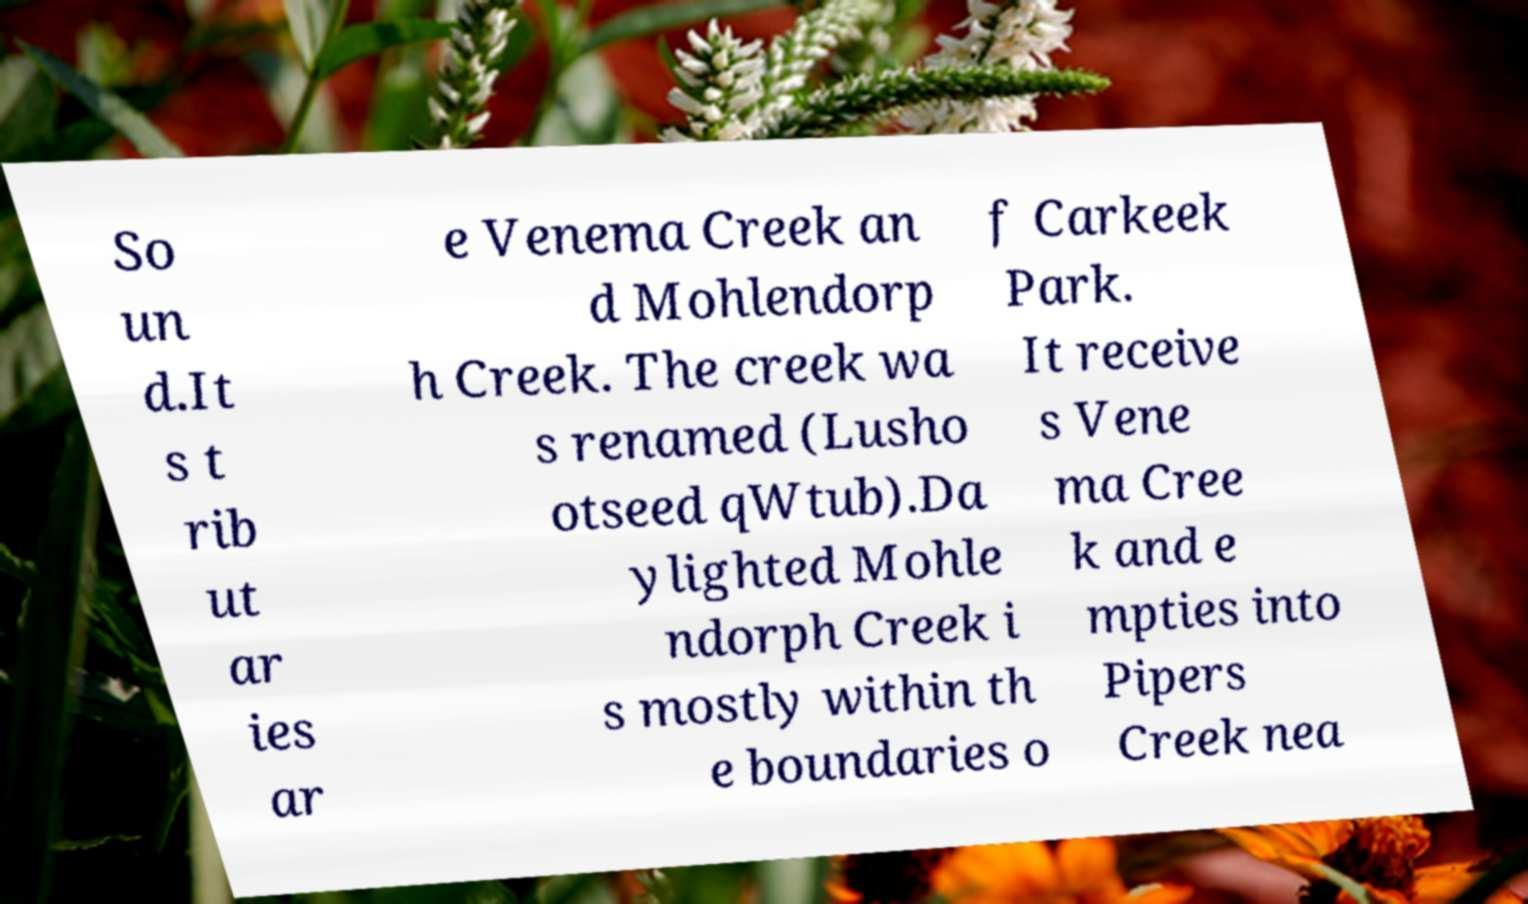There's text embedded in this image that I need extracted. Can you transcribe it verbatim? So un d.It s t rib ut ar ies ar e Venema Creek an d Mohlendorp h Creek. The creek wa s renamed (Lusho otseed qWtub).Da ylighted Mohle ndorph Creek i s mostly within th e boundaries o f Carkeek Park. It receive s Vene ma Cree k and e mpties into Pipers Creek nea 